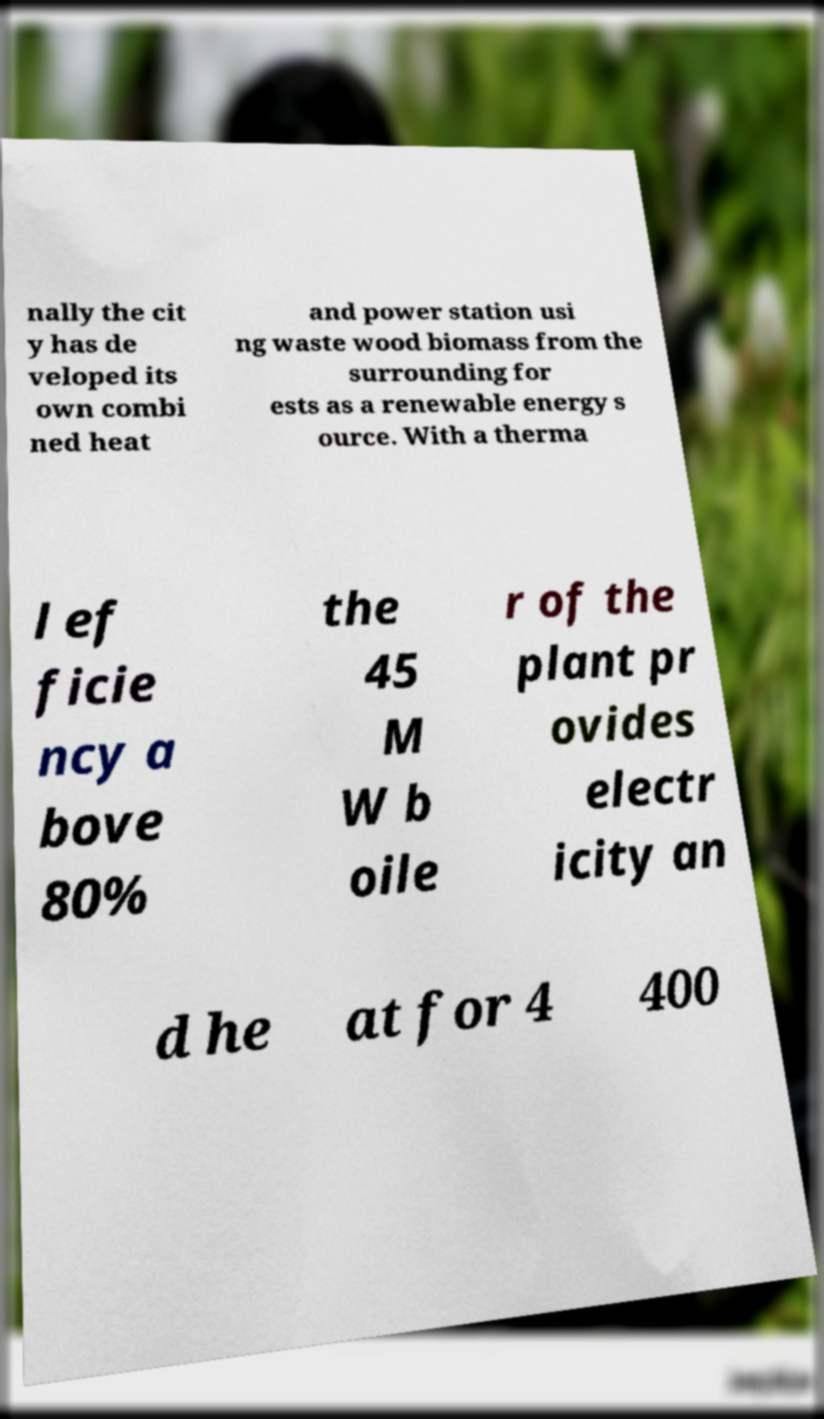Please identify and transcribe the text found in this image. nally the cit y has de veloped its own combi ned heat and power station usi ng waste wood biomass from the surrounding for ests as a renewable energy s ource. With a therma l ef ficie ncy a bove 80% the 45 M W b oile r of the plant pr ovides electr icity an d he at for 4 400 